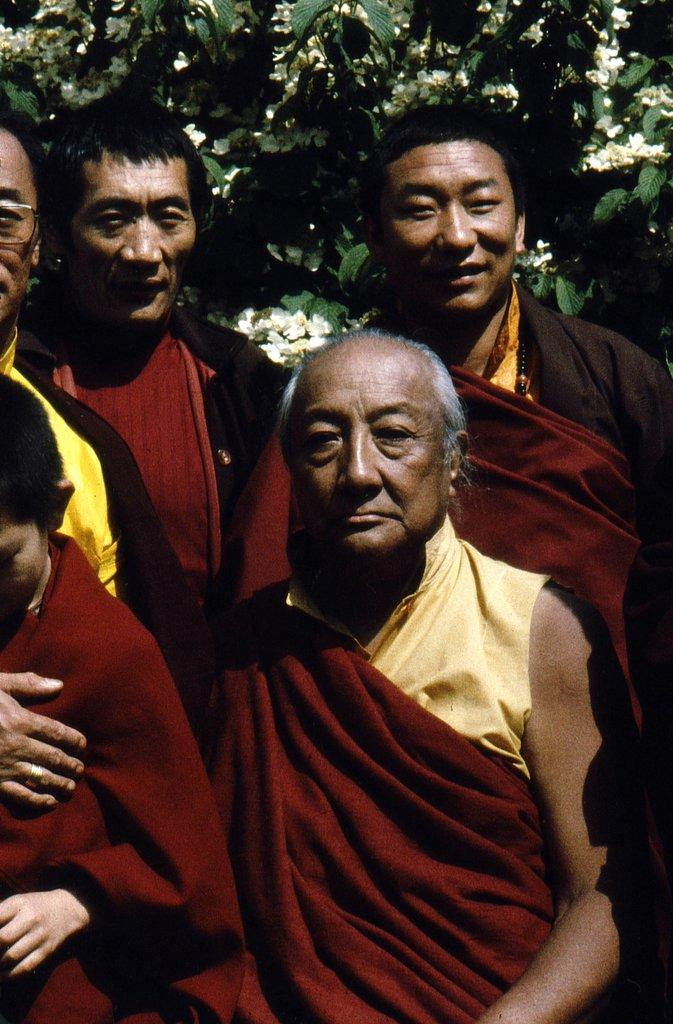What are the people in the image doing? The people in the image are standing on the ground. What can be seen in the background of the image? There is a tree with flowers in the background of the image. What type of rifle is being used by the person in the image? There is no rifle present in the image; the people are simply standing on the ground. What type of jeans are the persons wearing in the image? The provided facts do not mention the type of clothing the persons are wearing, so we cannot determine if they are wearing jeans or any other type of clothing. 